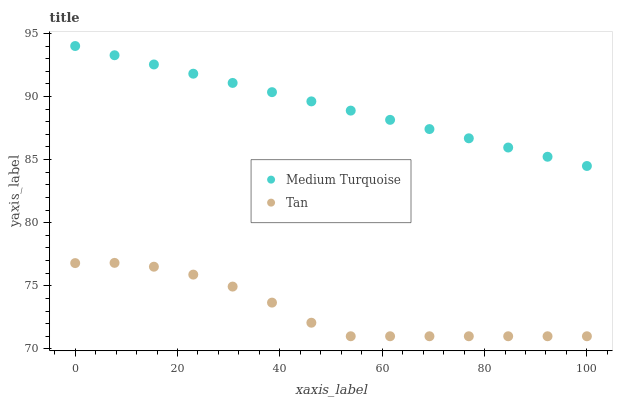Does Tan have the minimum area under the curve?
Answer yes or no. Yes. Does Medium Turquoise have the maximum area under the curve?
Answer yes or no. Yes. Does Medium Turquoise have the minimum area under the curve?
Answer yes or no. No. Is Medium Turquoise the smoothest?
Answer yes or no. Yes. Is Tan the roughest?
Answer yes or no. Yes. Is Medium Turquoise the roughest?
Answer yes or no. No. Does Tan have the lowest value?
Answer yes or no. Yes. Does Medium Turquoise have the lowest value?
Answer yes or no. No. Does Medium Turquoise have the highest value?
Answer yes or no. Yes. Is Tan less than Medium Turquoise?
Answer yes or no. Yes. Is Medium Turquoise greater than Tan?
Answer yes or no. Yes. Does Tan intersect Medium Turquoise?
Answer yes or no. No. 